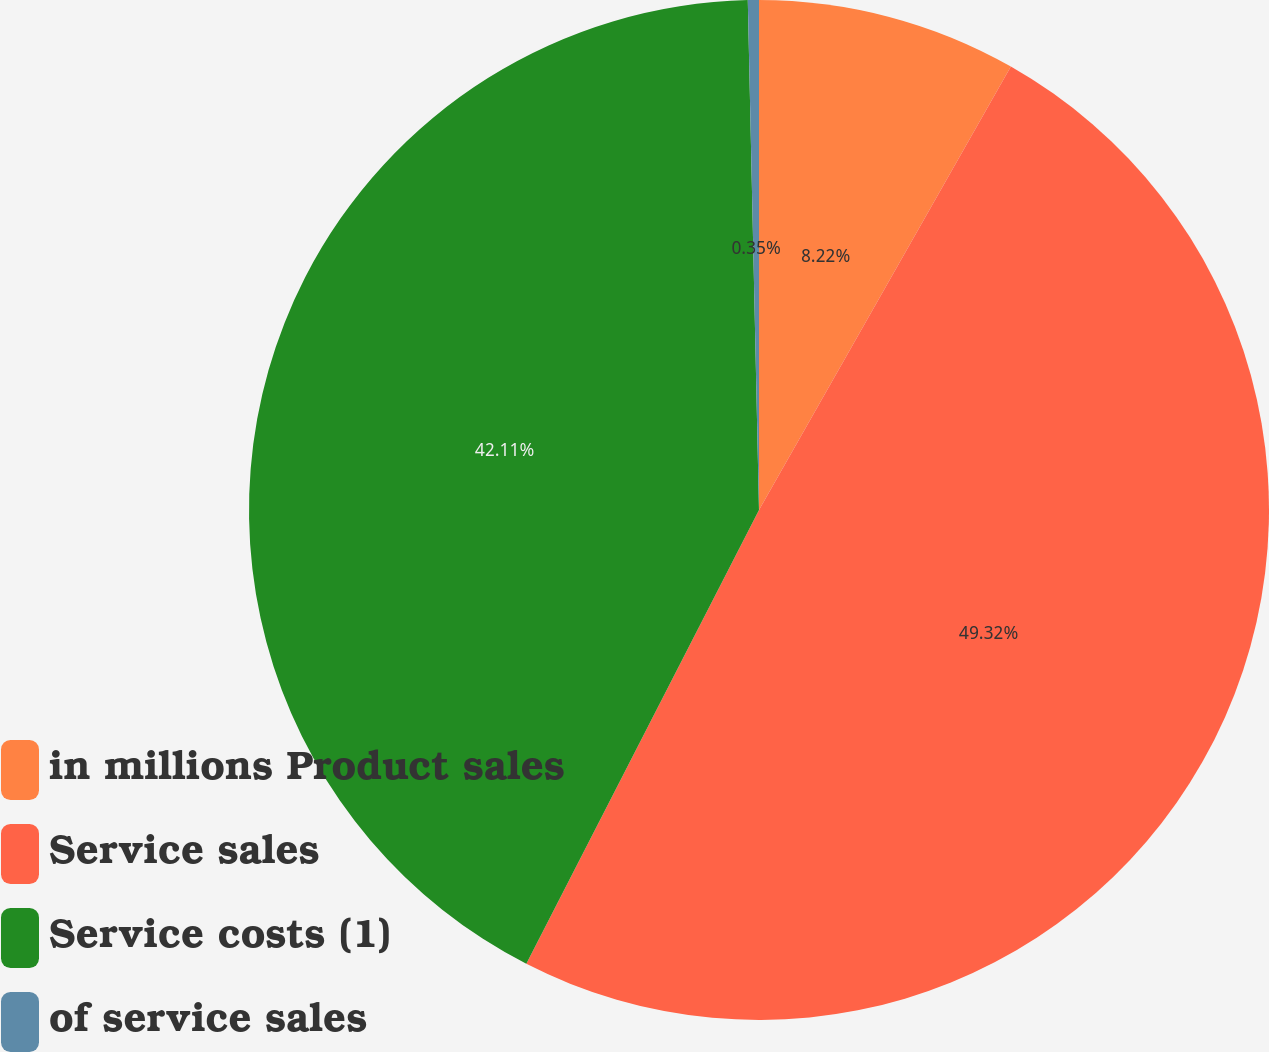Convert chart. <chart><loc_0><loc_0><loc_500><loc_500><pie_chart><fcel>in millions Product sales<fcel>Service sales<fcel>Service costs (1)<fcel>of service sales<nl><fcel>8.22%<fcel>49.32%<fcel>42.11%<fcel>0.35%<nl></chart> 